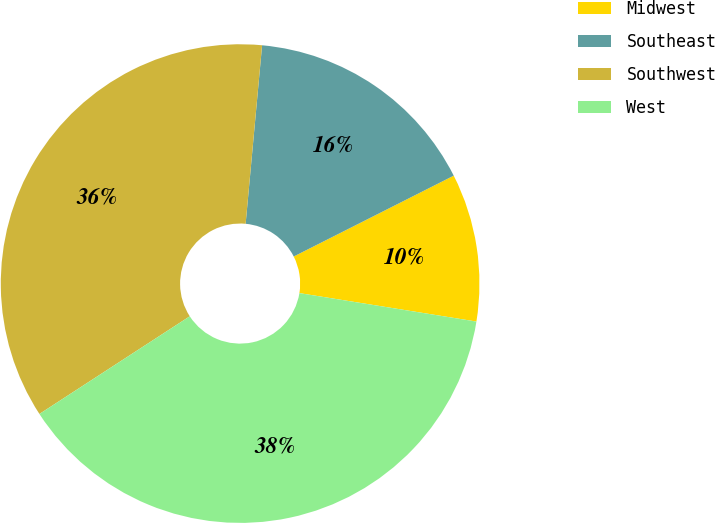Convert chart. <chart><loc_0><loc_0><loc_500><loc_500><pie_chart><fcel>Midwest<fcel>Southeast<fcel>Southwest<fcel>West<nl><fcel>9.98%<fcel>16.09%<fcel>35.63%<fcel>38.29%<nl></chart> 